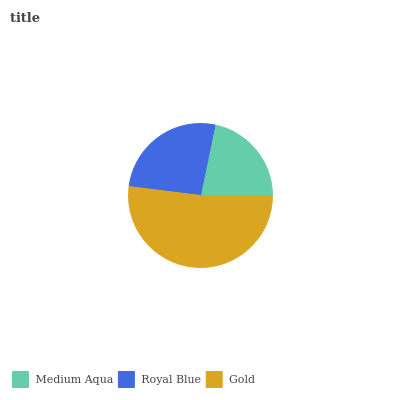Is Medium Aqua the minimum?
Answer yes or no. Yes. Is Gold the maximum?
Answer yes or no. Yes. Is Royal Blue the minimum?
Answer yes or no. No. Is Royal Blue the maximum?
Answer yes or no. No. Is Royal Blue greater than Medium Aqua?
Answer yes or no. Yes. Is Medium Aqua less than Royal Blue?
Answer yes or no. Yes. Is Medium Aqua greater than Royal Blue?
Answer yes or no. No. Is Royal Blue less than Medium Aqua?
Answer yes or no. No. Is Royal Blue the high median?
Answer yes or no. Yes. Is Royal Blue the low median?
Answer yes or no. Yes. Is Gold the high median?
Answer yes or no. No. Is Medium Aqua the low median?
Answer yes or no. No. 